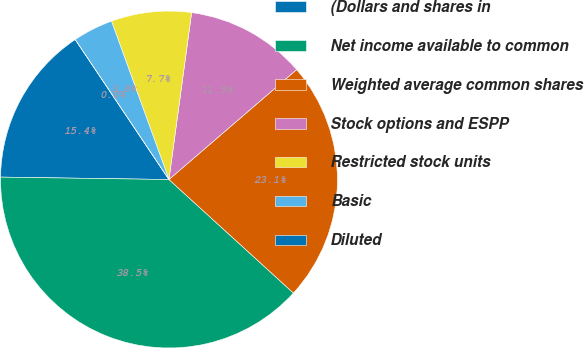Convert chart to OTSL. <chart><loc_0><loc_0><loc_500><loc_500><pie_chart><fcel>(Dollars and shares in<fcel>Net income available to common<fcel>Weighted average common shares<fcel>Stock options and ESPP<fcel>Restricted stock units<fcel>Basic<fcel>Diluted<nl><fcel>15.38%<fcel>38.46%<fcel>23.08%<fcel>11.54%<fcel>7.69%<fcel>3.85%<fcel>0.0%<nl></chart> 